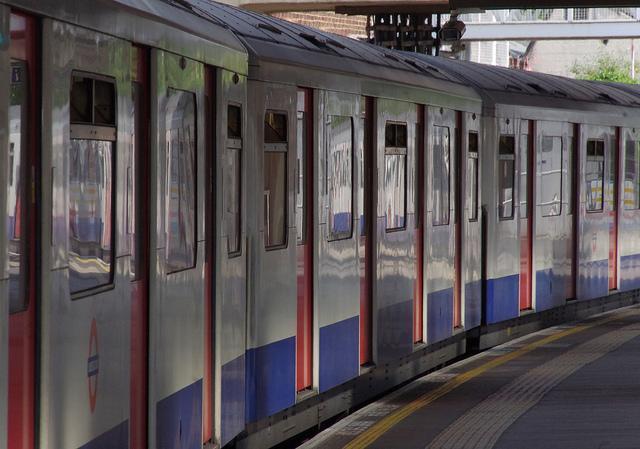How many windows are open?
Give a very brief answer. 7. 